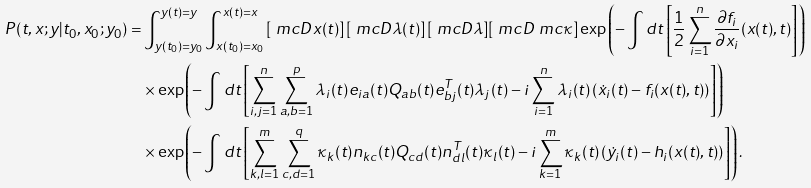<formula> <loc_0><loc_0><loc_500><loc_500>P ( t , x ; y | t _ { 0 } , x _ { 0 } ; y _ { 0 } ) = & \int _ { y ( t _ { 0 } ) = y _ { 0 } } ^ { y ( t ) = y } \int _ { x ( t _ { 0 } ) = x _ { 0 } } ^ { x ( t ) = x } \left [ \ m c { D } x ( t ) \right ] \left [ \ m c { D } \lambda ( t ) \right ] [ \ m c { D } \lambda ] [ \ m c { D } \ m c { \kappa } ] \exp \left ( - \int d t \left [ \frac { 1 } { 2 } \sum _ { i = 1 } ^ { n } \frac { \partial f _ { i } } { \partial x _ { i } } ( x ( t ) , t ) \right ] \right ) \\ & \times \exp \left ( - \int d t \left [ \sum _ { i , j = 1 } ^ { n } \sum _ { a , b = 1 } ^ { p } \lambda _ { i } ( t ) e _ { i a } ( t ) Q _ { a b } ( t ) e _ { b j } ^ { T } ( t ) \lambda _ { j } ( t ) - i \sum _ { i = 1 } ^ { n } \lambda _ { i } ( t ) \left ( \dot { x } _ { i } ( t ) - f _ { i } ( x ( t ) , t ) \right ) \right ] \right ) \\ & \times \exp \left ( - \int d t \left [ \sum _ { k , l = 1 } ^ { m } \sum _ { c , d = 1 } ^ { q } \kappa _ { k } ( t ) n _ { k c } ( t ) Q _ { c d } ( t ) n _ { d l } ^ { T } ( t ) \kappa _ { l } ( t ) - i \sum _ { k = 1 } ^ { m } \kappa _ { k } ( t ) \left ( \dot { y } _ { i } ( t ) - h _ { i } ( x ( t ) , t ) \right ) \right ] \right ) .</formula> 